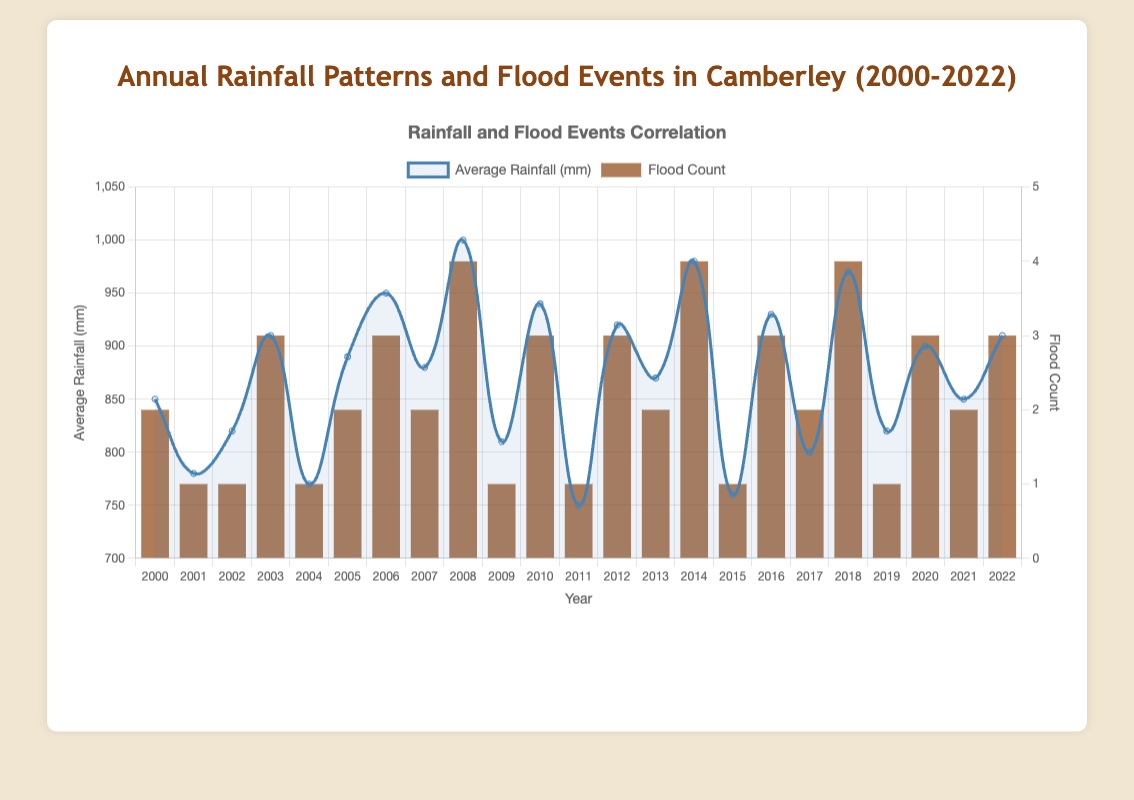What year had the highest average annual rainfall? To determine the year with the highest average rainfall, examine the peak points on the line representing annual rainfall. The highest peak occurs in 2008.
Answer: 2008 How many years had a flood count of 4? Count the bars with height equivalent to a flood count of 4 in the bar chart. There are 3 such years: 2008, 2014, and 2018.
Answer: 3 Is there a year where the average rainfall was 900 mm and the flood count was 3? Look for a point on the line chart at the 900 mm level and see if it aligns with a bar of height 3. This occurs in 2020.
Answer: 2020 Which year had a higher flood count: 2010 or 2020? Compare the height of the bars corresponding to 2010 and 2020. Both have a flood count of 3.
Answer: They are equal In which year did Camberley experience the highest flood count, and what was the average rainfall that year? Identify the year with the tallest bar, which signifies the highest flood count. The year is 2008, and by checking the line above it, the average rainfall was 1000 mm.
Answer: 2008, 1000 mm How does the flood count in 2017 compare to 2018? Compare the heights of the bars for 2017 and 2018. The bar in 2017 is lower (2) compared to the bar in 2018 (4).
Answer: 2018 has more What is the average flood count for the years with an average rainfall greater than 950 mm? First identify such years: 2008 (4), 2014 (4), and 2018 (4). Calculate the average flood count: (4 + 4 + 4) / 3 = 4.
Answer: 4 Which year had the largest increase in average rainfall compared to the previous year? Find the differences in average rainfall between consecutive years. The largest difference is between 2007 (880 mm) and 2008 (1000 mm) at 120 mm.
Answer: From 2007 to 2008 Does higher average rainfall always correspond to higher flood counts in the data? Compare instances of high average rainfall with corresponding flood counts. For example, 2008, 2014, and 2018 all fit this pattern, but it is not always consistent (2005 vs. 2006).
Answer: Not always 